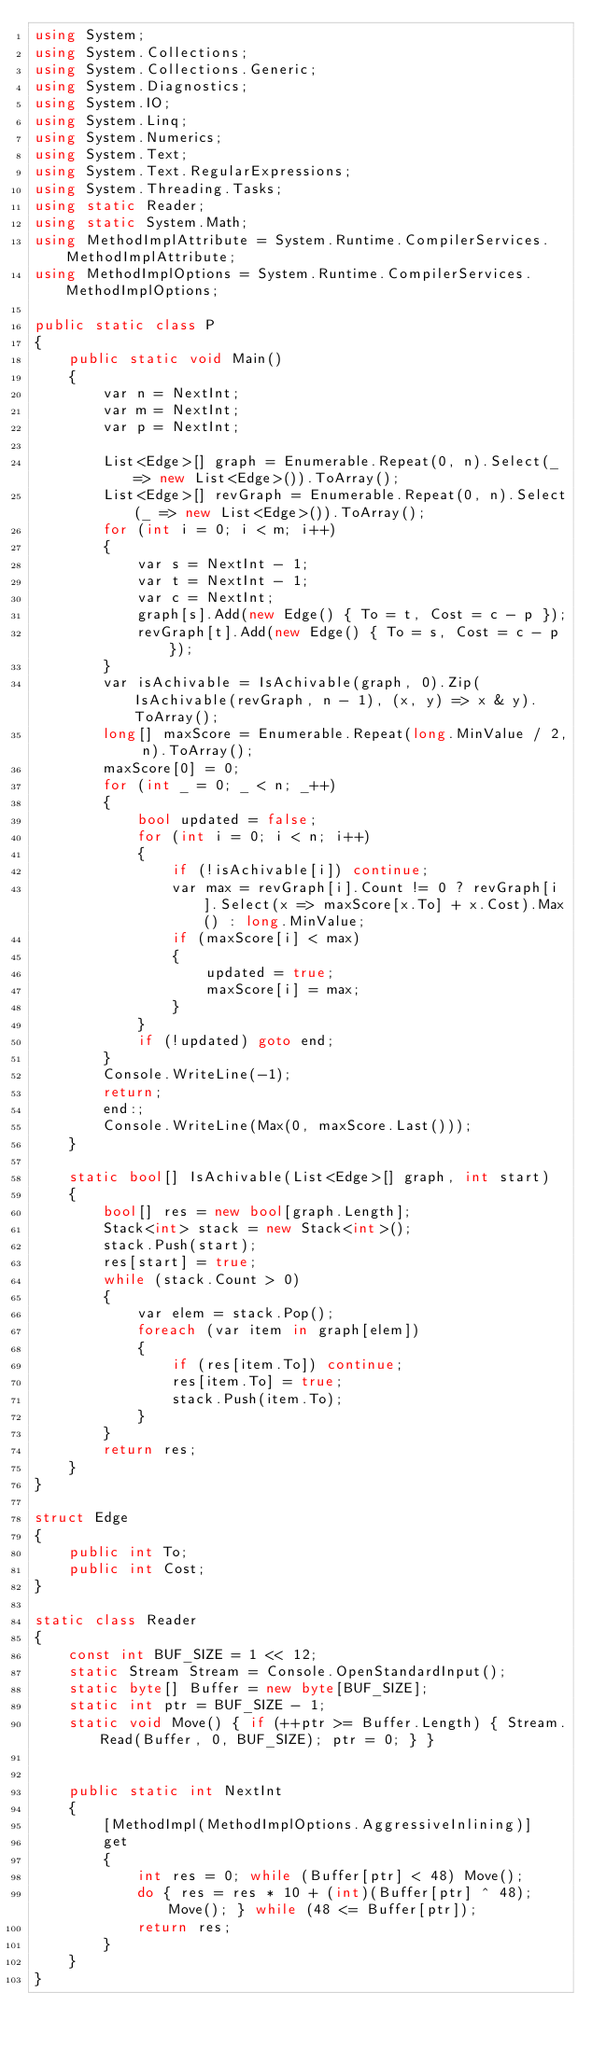Convert code to text. <code><loc_0><loc_0><loc_500><loc_500><_C#_>using System;
using System.Collections;
using System.Collections.Generic;
using System.Diagnostics;
using System.IO;
using System.Linq;
using System.Numerics;
using System.Text;
using System.Text.RegularExpressions;
using System.Threading.Tasks;
using static Reader;
using static System.Math;
using MethodImplAttribute = System.Runtime.CompilerServices.MethodImplAttribute;
using MethodImplOptions = System.Runtime.CompilerServices.MethodImplOptions;

public static class P
{
    public static void Main()
    {
        var n = NextInt;
        var m = NextInt;
        var p = NextInt;

        List<Edge>[] graph = Enumerable.Repeat(0, n).Select(_ => new List<Edge>()).ToArray();
        List<Edge>[] revGraph = Enumerable.Repeat(0, n).Select(_ => new List<Edge>()).ToArray();
        for (int i = 0; i < m; i++)
        {
            var s = NextInt - 1;
            var t = NextInt - 1;
            var c = NextInt;
            graph[s].Add(new Edge() { To = t, Cost = c - p });
            revGraph[t].Add(new Edge() { To = s, Cost = c - p });
        }
        var isAchivable = IsAchivable(graph, 0).Zip(IsAchivable(revGraph, n - 1), (x, y) => x & y).ToArray();
        long[] maxScore = Enumerable.Repeat(long.MinValue / 2, n).ToArray();
        maxScore[0] = 0;
        for (int _ = 0; _ < n; _++)
        {
            bool updated = false;
            for (int i = 0; i < n; i++)
            {
                if (!isAchivable[i]) continue;
                var max = revGraph[i].Count != 0 ? revGraph[i].Select(x => maxScore[x.To] + x.Cost).Max() : long.MinValue;
                if (maxScore[i] < max)
                {
                    updated = true;
                    maxScore[i] = max;
                }
            }
            if (!updated) goto end;
        }
        Console.WriteLine(-1);
        return;
        end:;
        Console.WriteLine(Max(0, maxScore.Last()));
    }

    static bool[] IsAchivable(List<Edge>[] graph, int start)
    {
        bool[] res = new bool[graph.Length];
        Stack<int> stack = new Stack<int>();
        stack.Push(start);
        res[start] = true;
        while (stack.Count > 0)
        {
            var elem = stack.Pop();
            foreach (var item in graph[elem])
            {
                if (res[item.To]) continue;
                res[item.To] = true;
                stack.Push(item.To);
            }
        }
        return res;
    }
}

struct Edge
{
    public int To;
    public int Cost;
}

static class Reader
{
    const int BUF_SIZE = 1 << 12;
    static Stream Stream = Console.OpenStandardInput();
    static byte[] Buffer = new byte[BUF_SIZE];
    static int ptr = BUF_SIZE - 1;
    static void Move() { if (++ptr >= Buffer.Length) { Stream.Read(Buffer, 0, BUF_SIZE); ptr = 0; } }


    public static int NextInt
    {
        [MethodImpl(MethodImplOptions.AggressiveInlining)]
        get
        {
            int res = 0; while (Buffer[ptr] < 48) Move();
            do { res = res * 10 + (int)(Buffer[ptr] ^ 48); Move(); } while (48 <= Buffer[ptr]);
            return res;
        }
    }
}
</code> 